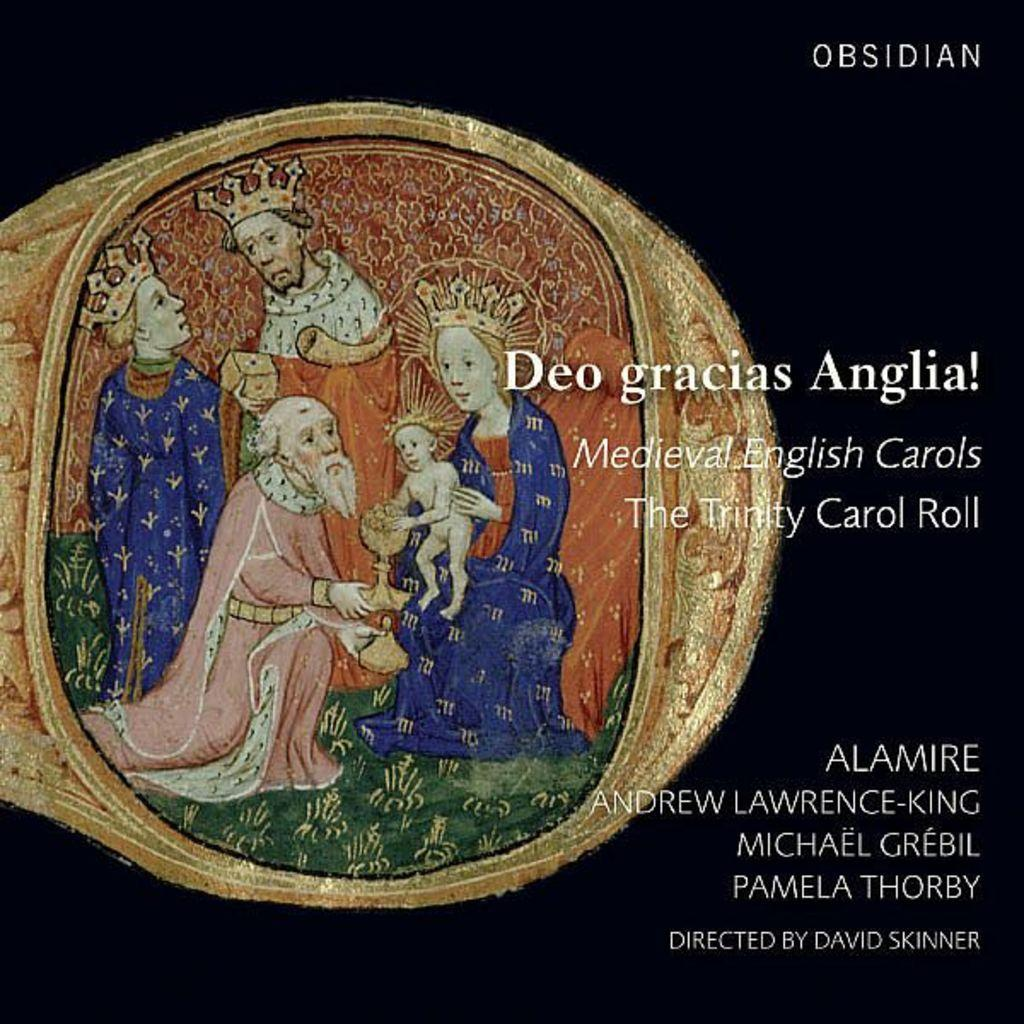What is the main subject of the image? The main subject of the image is a painting. What is depicted in the painting? The painting depicts four people and a kid. Is there any text associated with the painting? Yes, there is text associated with the painting. What type of linen is used to create the painting in the image? There is no information about the type of linen used to create the painting in the image. Can you see any wrens in the painting? There are no wrens depicted in the painting; it features four people and a kid. 